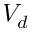<formula> <loc_0><loc_0><loc_500><loc_500>V _ { d }</formula> 